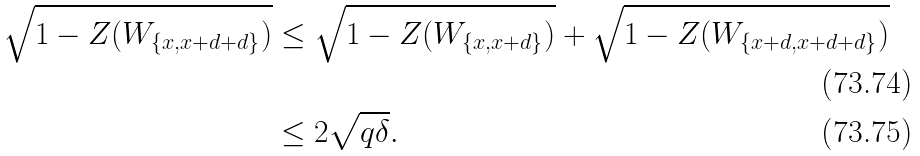Convert formula to latex. <formula><loc_0><loc_0><loc_500><loc_500>\sqrt { 1 - Z ( W _ { \{ x , x + d + d \} } ) } & \leq \sqrt { 1 - Z ( W _ { \{ x , x + d \} } ) } + \sqrt { 1 - Z ( W _ { \{ x + d , x + d + d \} } ) } \\ & \leq 2 \sqrt { q \delta } .</formula> 